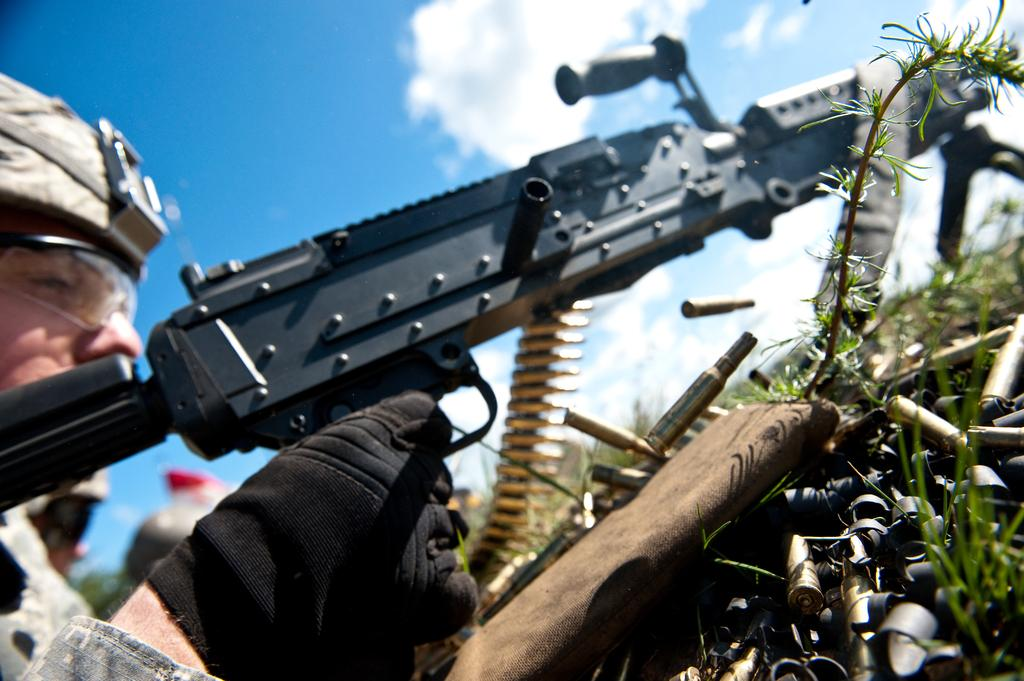What is the main subject of the image? There is a person in the image. What is the person holding in the image? The person is holding a gun. What type of clothing is the person wearing? The person is wearing military dress. What color are the gloves the person is wearing? The person is wearing black color gloves. What type of vegetation can be seen in the image? There is green grass in the image. What colors are visible in the sky in the image? The sky is in white and blue color. How many bricks can be seen in the image? There are no bricks present in the image. Is there a cellar visible in the image? There is no cellar present in the image. 